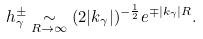Convert formula to latex. <formula><loc_0><loc_0><loc_500><loc_500>h _ { \gamma } ^ { \pm } \underset { R \rightarrow \infty } { \sim } ( 2 | k _ { \gamma } | ) ^ { - \frac { 1 } { 2 } } e ^ { \mp | k _ { \gamma } | R } .</formula> 